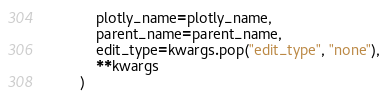<code> <loc_0><loc_0><loc_500><loc_500><_Python_>            plotly_name=plotly_name,
            parent_name=parent_name,
            edit_type=kwargs.pop("edit_type", "none"),
            **kwargs
        )
</code> 